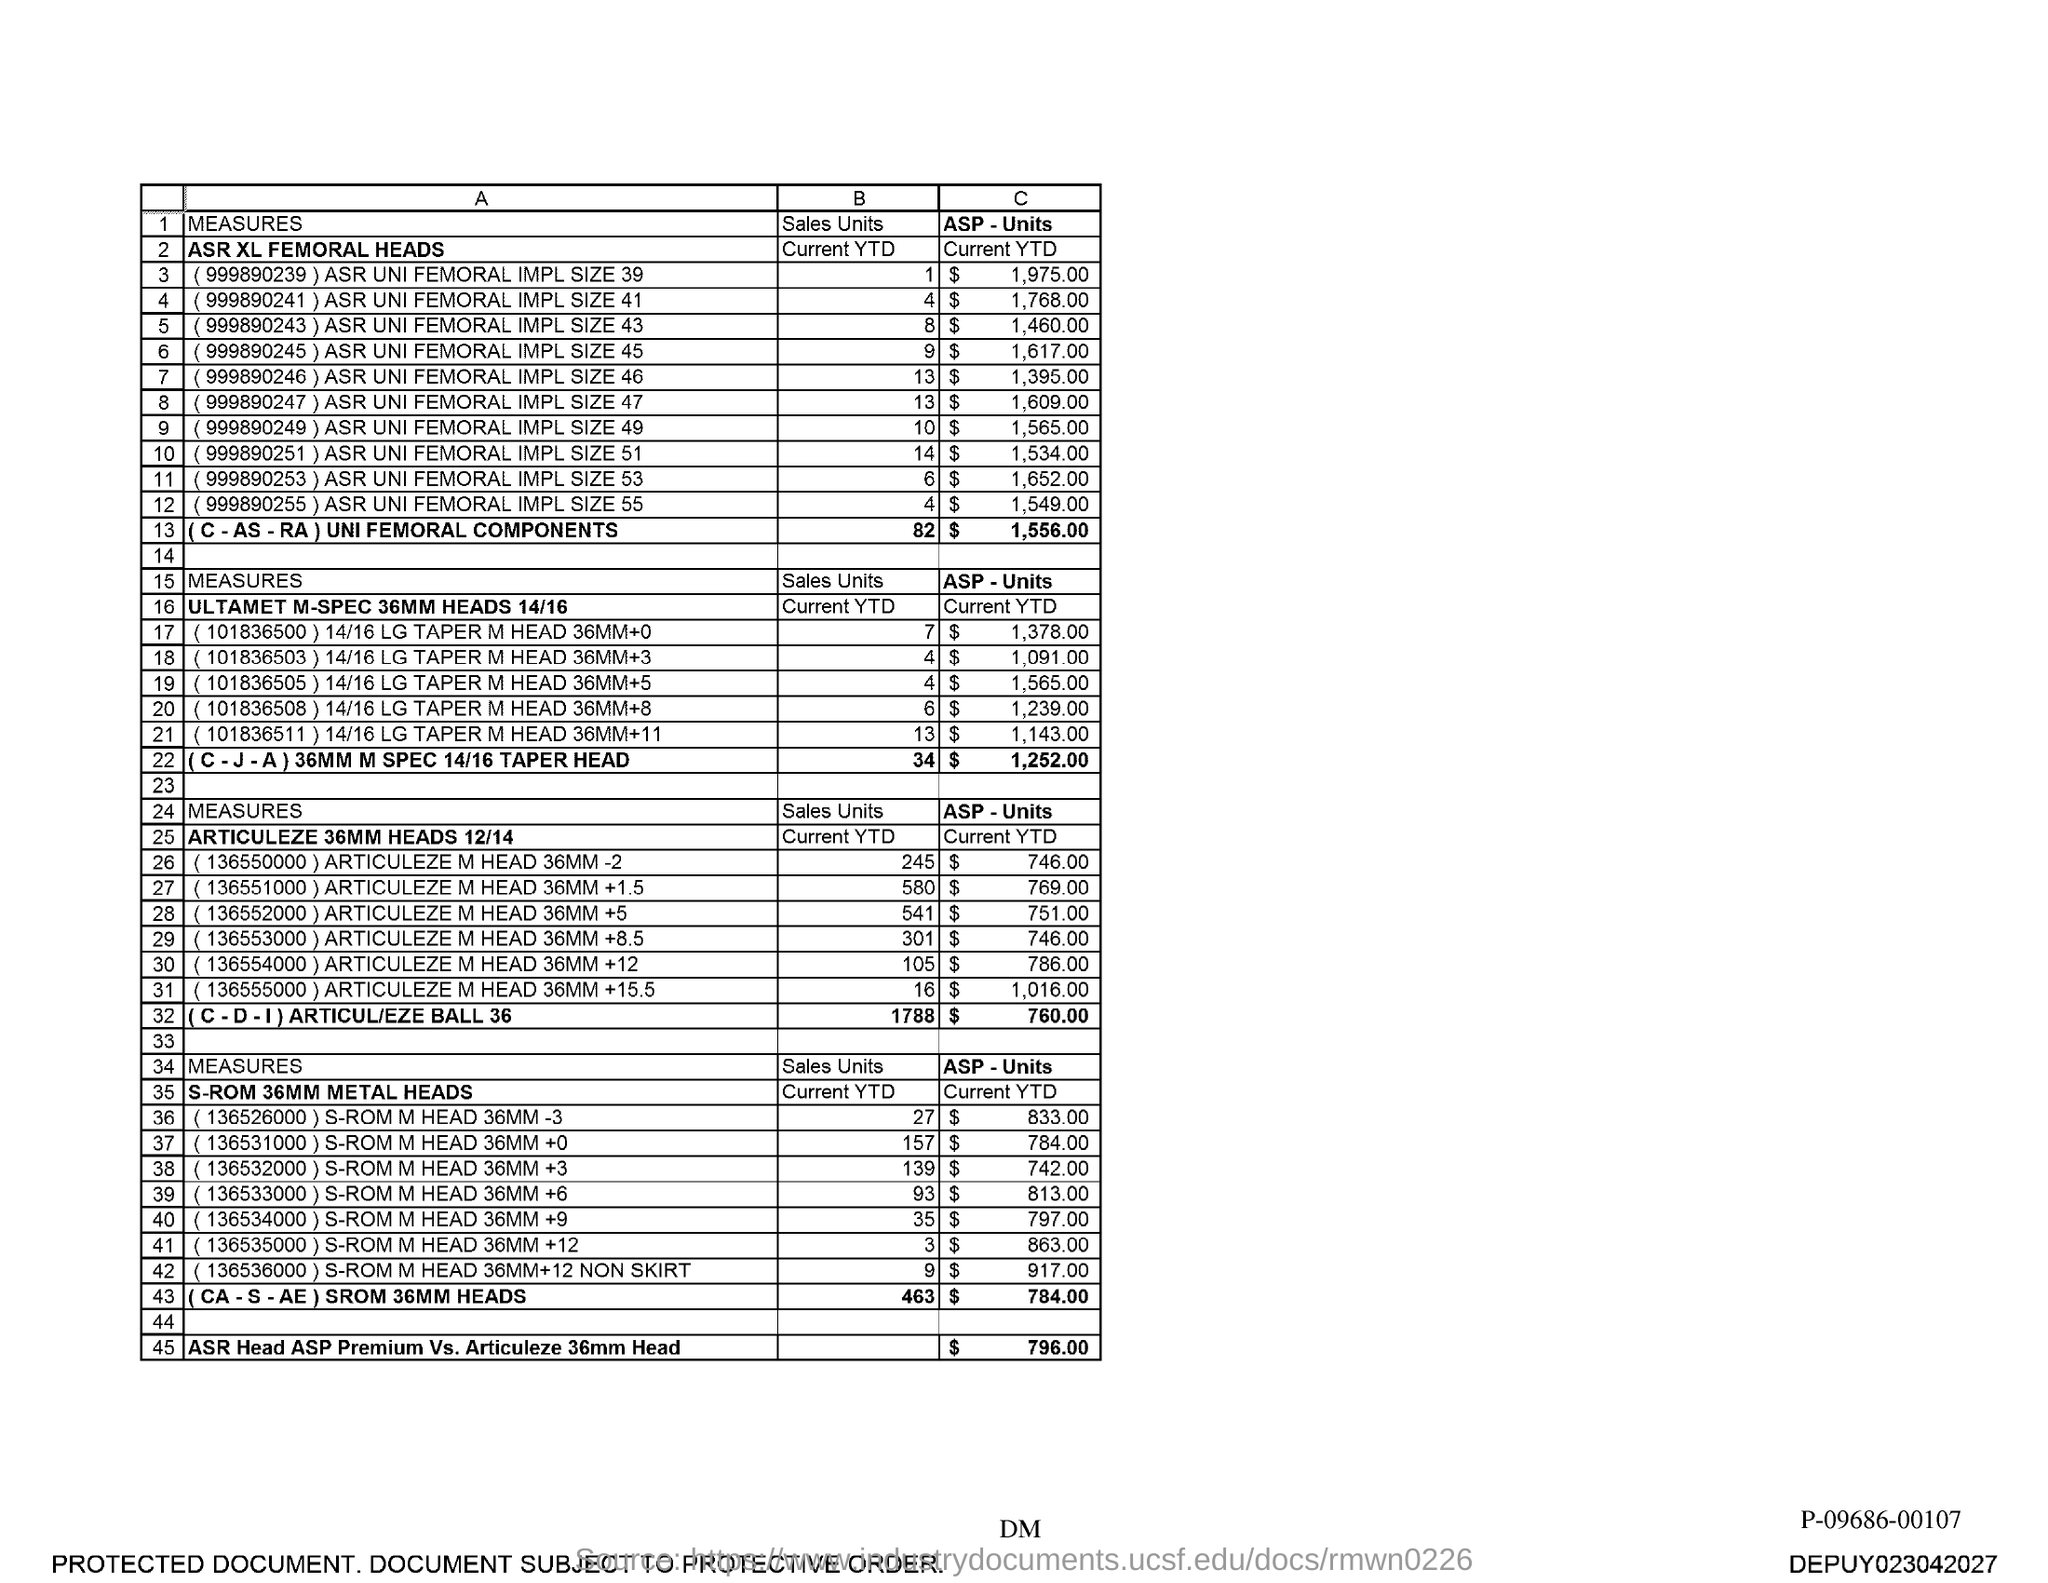What is the ASP-Units of ASR Head ASP Premium Vs.Articuleze 36mm Head?
Provide a short and direct response. $ 796.00. 